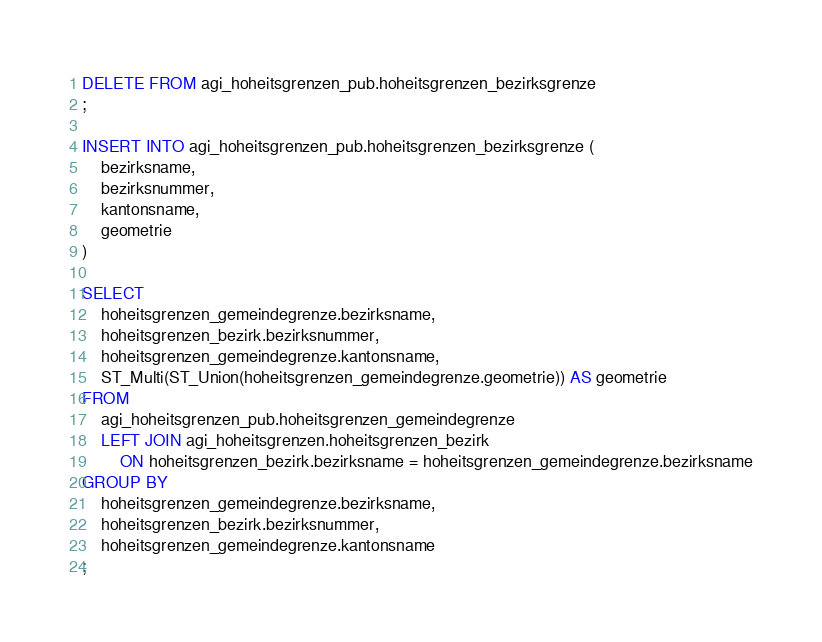Convert code to text. <code><loc_0><loc_0><loc_500><loc_500><_SQL_>DELETE FROM agi_hoheitsgrenzen_pub.hoheitsgrenzen_bezirksgrenze
;

INSERT INTO agi_hoheitsgrenzen_pub.hoheitsgrenzen_bezirksgrenze (
    bezirksname,
    bezirksnummer,
    kantonsname,
    geometrie
)

SELECT
    hoheitsgrenzen_gemeindegrenze.bezirksname,
    hoheitsgrenzen_bezirk.bezirksnummer,
    hoheitsgrenzen_gemeindegrenze.kantonsname,
    ST_Multi(ST_Union(hoheitsgrenzen_gemeindegrenze.geometrie)) AS geometrie
FROM
    agi_hoheitsgrenzen_pub.hoheitsgrenzen_gemeindegrenze
    LEFT JOIN agi_hoheitsgrenzen.hoheitsgrenzen_bezirk
        ON hoheitsgrenzen_bezirk.bezirksname = hoheitsgrenzen_gemeindegrenze.bezirksname
GROUP BY
    hoheitsgrenzen_gemeindegrenze.bezirksname,
    hoheitsgrenzen_bezirk.bezirksnummer,
    hoheitsgrenzen_gemeindegrenze.kantonsname
;</code> 